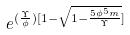Convert formula to latex. <formula><loc_0><loc_0><loc_500><loc_500>e ^ { ( \frac { \Upsilon } { \phi } ) [ 1 - \sqrt { 1 - \frac { 5 \phi ^ { 5 } m } { \Upsilon } } ] }</formula> 